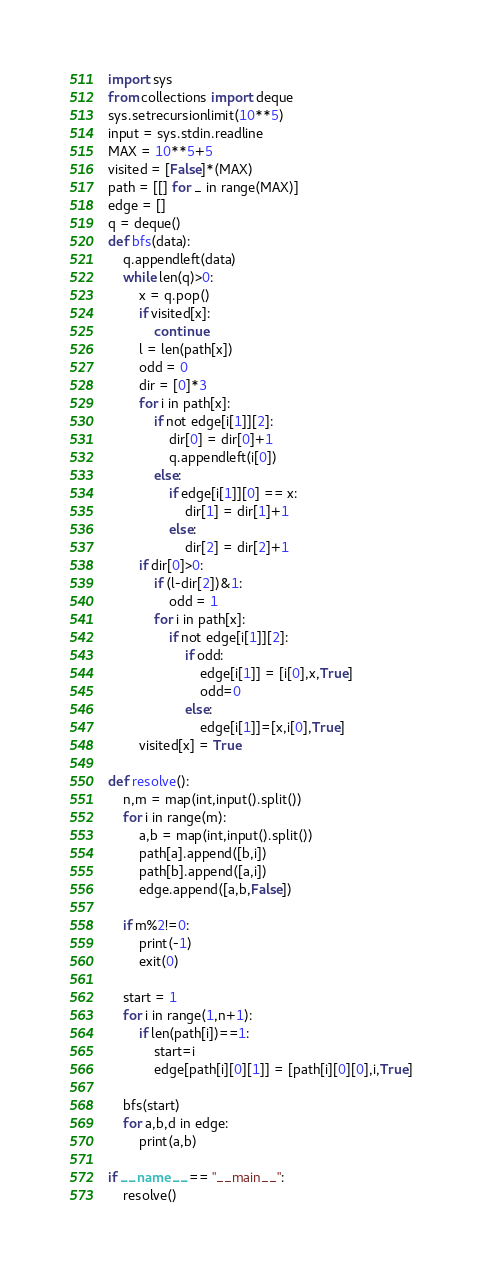Convert code to text. <code><loc_0><loc_0><loc_500><loc_500><_Python_>import sys
from collections import deque
sys.setrecursionlimit(10**5)
input = sys.stdin.readline
MAX = 10**5+5
visited = [False]*(MAX)
path = [[] for _ in range(MAX)]
edge = []
q = deque()
def bfs(data):
    q.appendleft(data)
    while len(q)>0:
        x = q.pop()
        if visited[x]:
            continue
        l = len(path[x])
        odd = 0
        dir = [0]*3
        for i in path[x]:
            if not edge[i[1]][2]:
                dir[0] = dir[0]+1
                q.appendleft(i[0])
            else:
                if edge[i[1]][0] == x:
                    dir[1] = dir[1]+1
                else:
                    dir[2] = dir[2]+1
        if dir[0]>0:
            if (l-dir[2])&1:
                odd = 1
            for i in path[x]:
                if not edge[i[1]][2]:
                    if odd:
                        edge[i[1]] = [i[0],x,True]
                        odd=0
                    else:
                        edge[i[1]]=[x,i[0],True]
        visited[x] = True

def resolve():
    n,m = map(int,input().split())
    for i in range(m):
        a,b = map(int,input().split())
        path[a].append([b,i])
        path[b].append([a,i])
        edge.append([a,b,False])

    if m%2!=0:
        print(-1)
        exit(0)
    
    start = 1
    for i in range(1,n+1):
        if len(path[i])==1:
            start=i
            edge[path[i][0][1]] = [path[i][0][0],i,True]
        
    bfs(start)
    for a,b,d in edge:
        print(a,b)

if __name__ == "__main__":
    resolve()</code> 